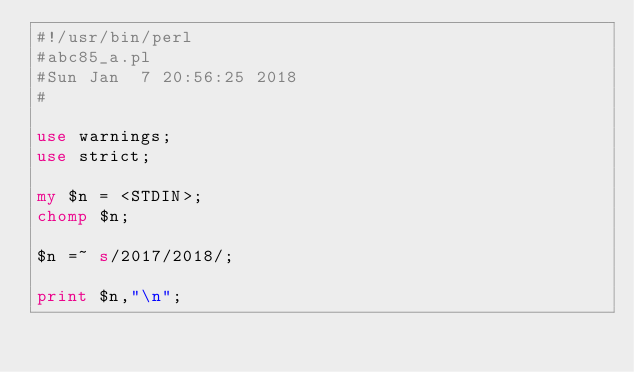Convert code to text. <code><loc_0><loc_0><loc_500><loc_500><_Perl_>#!/usr/bin/perl
#abc85_a.pl
#Sun Jan  7 20:56:25 2018
#

use warnings;
use strict;

my $n = <STDIN>;
chomp $n;

$n =~ s/2017/2018/;

print $n,"\n";</code> 